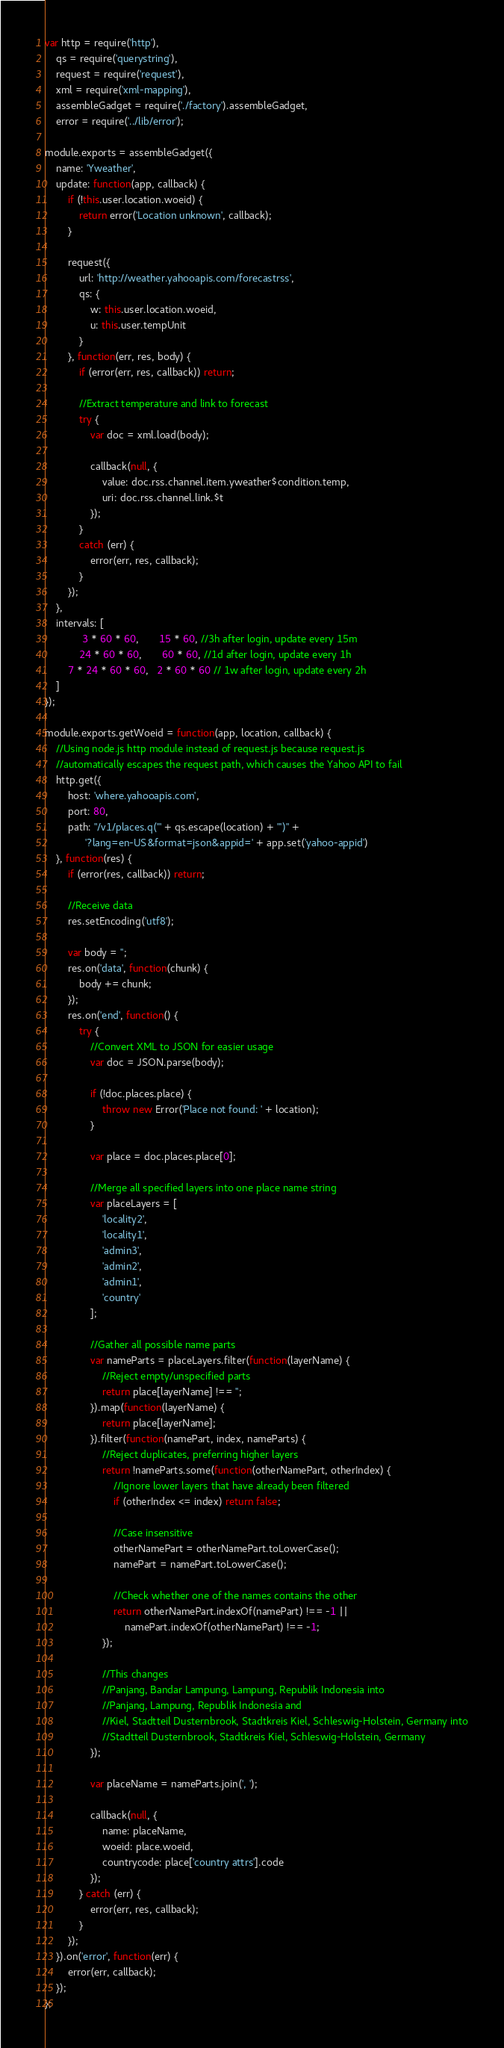Convert code to text. <code><loc_0><loc_0><loc_500><loc_500><_JavaScript_>var http = require('http'),
	qs = require('querystring'),
	request = require('request'),
	xml = require('xml-mapping'),
	assembleGadget = require('./factory').assembleGadget,
	error = require('../lib/error');

module.exports = assembleGadget({
	name: 'Yweather',
	update: function(app, callback) {
		if (!this.user.location.woeid) {
			return error('Location unknown', callback);
		}

		request({
			url: 'http://weather.yahooapis.com/forecastrss',
			qs: {
				w: this.user.location.woeid,
				u: this.user.tempUnit
			}
		}, function(err, res, body) {
			if (error(err, res, callback)) return;

			//Extract temperature and link to forecast
			try {
				var doc = xml.load(body);

				callback(null, {
					value: doc.rss.channel.item.yweather$condition.temp,
					uri: doc.rss.channel.link.$t
				});
			}
			catch (err) {
				error(err, res, callback);
			}
		});
	},
	intervals: [
		     3 * 60 * 60,       15 * 60, //3h after login, update every 15m
		    24 * 60 * 60,       60 * 60, //1d after login, update every 1h
		7 * 24 * 60 * 60,   2 * 60 * 60 // 1w after login, update every 2h
	]
});

module.exports.getWoeid = function(app, location, callback) {
	//Using node.js http module instead of request.js because request.js
	//automatically escapes the request path, which causes the Yahoo API to fail
	http.get({
		host: 'where.yahooapis.com',
		port: 80,
		path: "/v1/places.q('" + qs.escape(location) + "')" +
			  '?lang=en-US&format=json&appid=' + app.set('yahoo-appid')
	}, function(res) {
		if (error(res, callback)) return;

		//Receive data
		res.setEncoding('utf8');

		var body = '';
		res.on('data', function(chunk) {
			body += chunk;
		});
		res.on('end', function() {
			try {
				//Convert XML to JSON for easier usage
				var doc = JSON.parse(body);

				if (!doc.places.place) {
					throw new Error('Place not found: ' + location);
				}

				var place = doc.places.place[0];

				//Merge all specified layers into one place name string
				var placeLayers = [ 
					'locality2',
					'locality1',
					'admin3',
					'admin2',
					'admin1',
					'country'
				];

				//Gather all possible name parts
				var nameParts = placeLayers.filter(function(layerName) {
					//Reject empty/unspecified parts
					return place[layerName] !== '';
				}).map(function(layerName) {
					return place[layerName];
				}).filter(function(namePart, index, nameParts) {
					//Reject duplicates, preferring higher layers
					return !nameParts.some(function(otherNamePart, otherIndex) {
						//Ignore lower layers that have already been filtered
						if (otherIndex <= index) return false;

						//Case insensitive
						otherNamePart = otherNamePart.toLowerCase();
						namePart = namePart.toLowerCase();

						//Check whether one of the names contains the other
						return otherNamePart.indexOf(namePart) !== -1 ||
							namePart.indexOf(otherNamePart) !== -1;
					});

					//This changes
					//Panjang, Bandar Lampung, Lampung, Republik Indonesia into
					//Panjang, Lampung, Republik Indonesia and
					//Kiel, Stadtteil Dusternbrook, Stadtkreis Kiel, Schleswig-Holstein, Germany into
					//Stadtteil Dusternbrook, Stadtkreis Kiel, Schleswig-Holstein, Germany
				});

				var placeName = nameParts.join(', ');

				callback(null, {
					name: placeName,
					woeid: place.woeid,
					countrycode: place['country attrs'].code
				});
			} catch (err) {
				error(err, res, callback);
			}
		});
	}).on('error', function(err) {
		error(err, callback);
	});
};</code> 